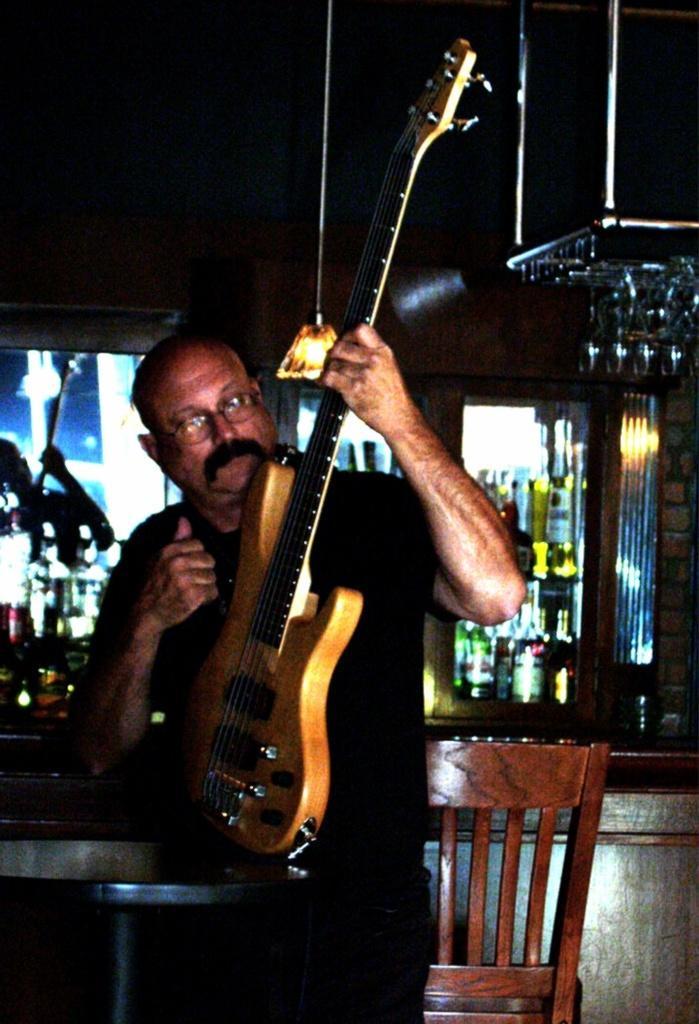In one or two sentences, can you explain what this image depicts? In this picture we can see a man who is holding a guitar with his hands. This is chair. And there are bottles and this is light. 